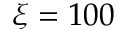Convert formula to latex. <formula><loc_0><loc_0><loc_500><loc_500>\xi = 1 0 0</formula> 